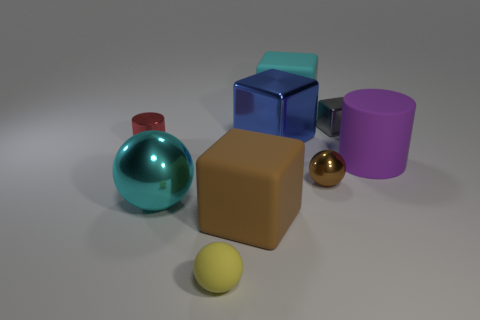Subtract all cylinders. How many objects are left? 7 Add 8 red things. How many red things exist? 9 Subtract 0 green balls. How many objects are left? 9 Subtract all cubes. Subtract all small metallic spheres. How many objects are left? 4 Add 3 small yellow objects. How many small yellow objects are left? 4 